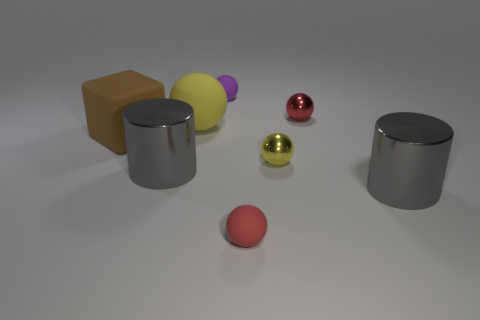There is another tiny matte thing that is the same shape as the red matte thing; what color is it?
Ensure brevity in your answer.  Purple. What size is the purple matte thing that is the same shape as the small red rubber thing?
Offer a terse response. Small. What number of things are right of the purple thing and in front of the block?
Provide a short and direct response. 3. What number of other objects are there of the same material as the large yellow sphere?
Offer a terse response. 3. Does the tiny red thing that is behind the big brown thing have the same material as the brown thing?
Your answer should be very brief. No. What size is the red thing that is behind the gray object to the left of the tiny purple ball that is on the right side of the large yellow rubber object?
Your answer should be very brief. Small. How many other objects are there of the same color as the large rubber sphere?
Offer a very short reply. 1. What shape is the other rubber thing that is the same size as the purple object?
Make the answer very short. Sphere. There is a red sphere right of the tiny yellow object; what is its size?
Ensure brevity in your answer.  Small. Does the metal object that is behind the small yellow shiny ball have the same color as the large metallic thing that is right of the small yellow sphere?
Give a very brief answer. No. 